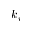Convert formula to latex. <formula><loc_0><loc_0><loc_500><loc_500>k _ { i }</formula> 